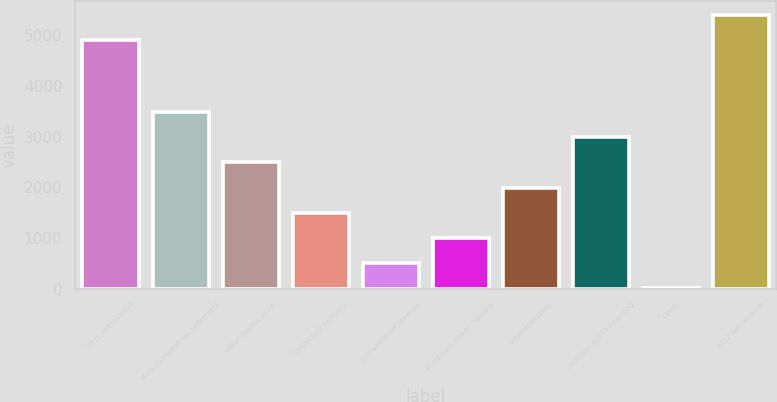Convert chart. <chart><loc_0><loc_0><loc_500><loc_500><bar_chart><fcel>2011 net revenue<fcel>Mark-to-market tax settlement<fcel>Retail electric price<fcel>Grand Gulf recovery<fcel>Net wholesale revenue<fcel>Purchased power capacity<fcel>Volume/weather<fcel>Louisiana Act 55 financing<fcel>Other<fcel>2012 net revenue<nl><fcel>4904<fcel>3481.6<fcel>2490<fcel>1498.4<fcel>506.8<fcel>1002.6<fcel>1994.2<fcel>2985.8<fcel>11<fcel>5399.8<nl></chart> 